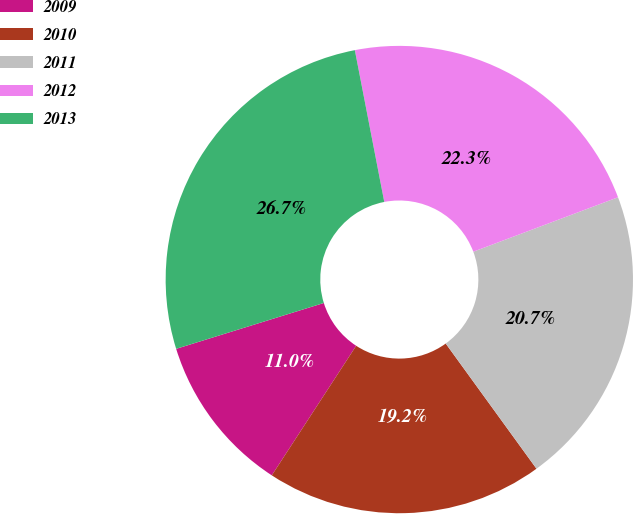Convert chart to OTSL. <chart><loc_0><loc_0><loc_500><loc_500><pie_chart><fcel>2009<fcel>2010<fcel>2011<fcel>2012<fcel>2013<nl><fcel>11.02%<fcel>19.17%<fcel>20.74%<fcel>22.32%<fcel>26.74%<nl></chart> 